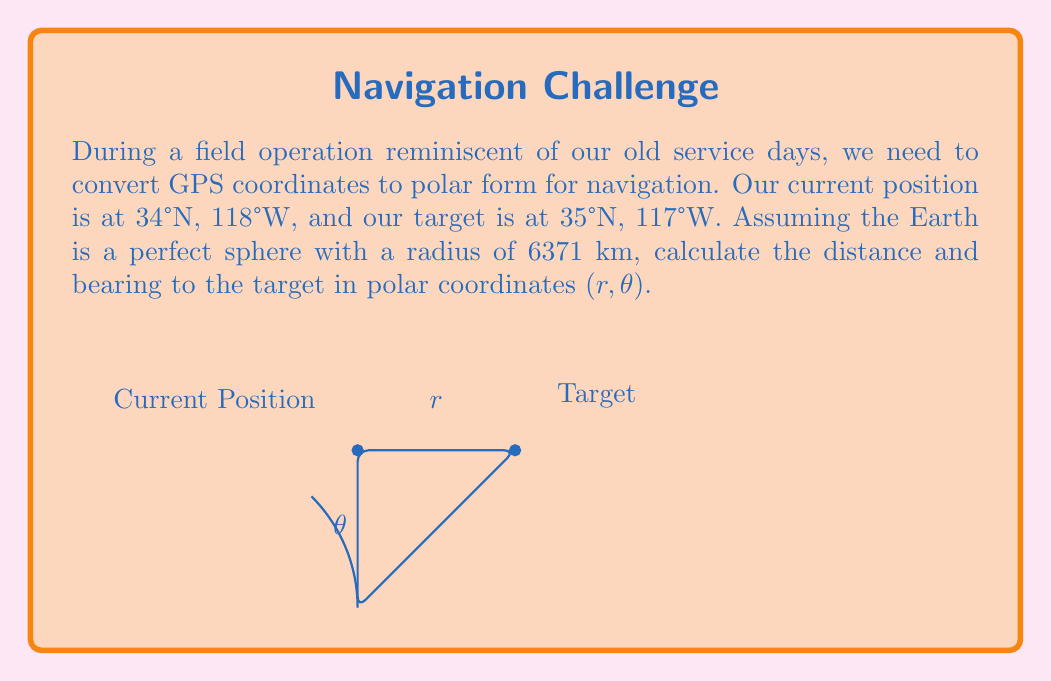Solve this math problem. To solve this problem, we'll follow these steps:

1) Convert the latitude and longitude to radians:
   Current: $\phi_1 = 34° \cdot \frac{\pi}{180} = 0.5934$ rad, $\lambda_1 = -118° \cdot \frac{\pi}{180} = -2.0594$ rad
   Target: $\phi_2 = 35° \cdot \frac{\pi}{180} = 0.6109$ rad, $\lambda_2 = -117° \cdot \frac{\pi}{180} = -2.0420$ rad

2) Calculate the difference in longitude:
   $\Delta\lambda = \lambda_2 - \lambda_1 = 0.0174$ rad

3) Use the haversine formula to calculate the central angle $\Delta\sigma$:
   $$\Delta\sigma = 2 \arcsin\left(\sqrt{\sin^2\left(\frac{\Delta\phi}{2}\right) + \cos\phi_1 \cos\phi_2 \sin^2\left(\frac{\Delta\lambda}{2}\right)}\right)$$
   $$\Delta\sigma = 2 \arcsin\left(\sqrt{\sin^2\left(\frac{0.6109 - 0.5934}{2}\right) + \cos(0.5934) \cos(0.6109) \sin^2\left(\frac{0.0174}{2}\right)}\right)$$
   $$\Delta\sigma = 0.0204$$ rad

4) Calculate the distance $r$:
   $r = R \cdot \Delta\sigma = 6371 \cdot 0.0204 = 129.9684$ km

5) Calculate the bearing $\theta$ using the formula:
   $$\theta = \arctan2(\sin\Delta\lambda \cos\phi_2, \cos\phi_1 \sin\phi_2 - \sin\phi_1 \cos\phi_2 \cos\Delta\lambda)$$
   $$\theta = \arctan2(\sin(0.0174) \cos(0.6109), \cos(0.5934) \sin(0.6109) - \sin(0.5934) \cos(0.6109) \cos(0.0174))$$
   $$\theta = 0.4588$$ rad

6) Convert the bearing to degrees:
   $\theta = 0.4588 \cdot \frac{180}{\pi} = 26.2933°$

Therefore, the polar coordinates (r, θ) are approximately (129.97 km, 26.29°).
Answer: (129.97 km, 26.29°) 